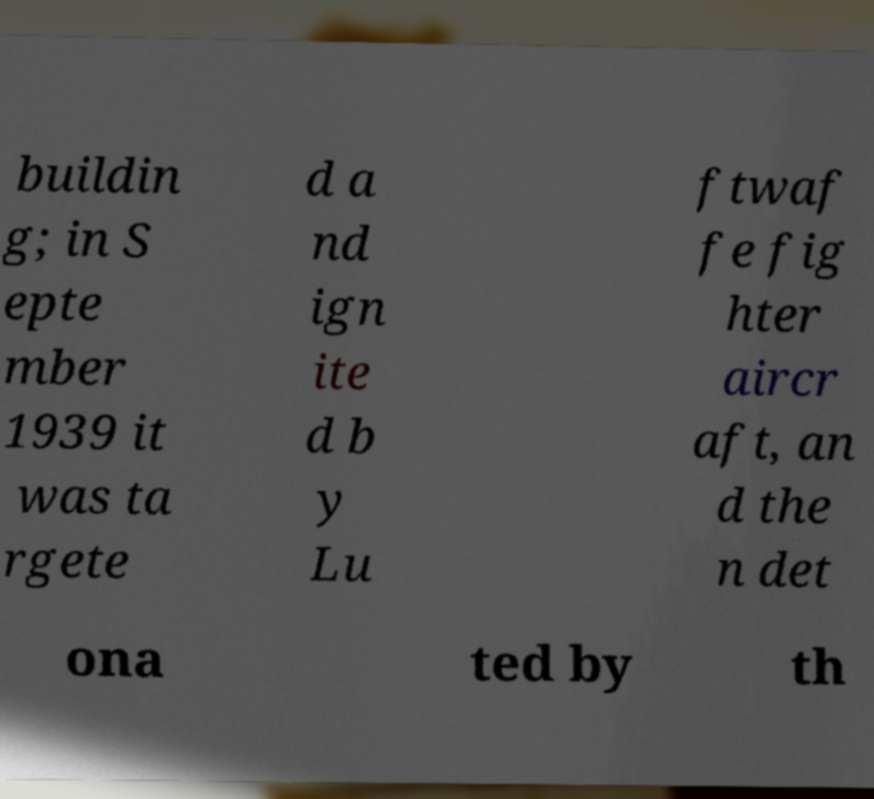Could you extract and type out the text from this image? buildin g; in S epte mber 1939 it was ta rgete d a nd ign ite d b y Lu ftwaf fe fig hter aircr aft, an d the n det ona ted by th 